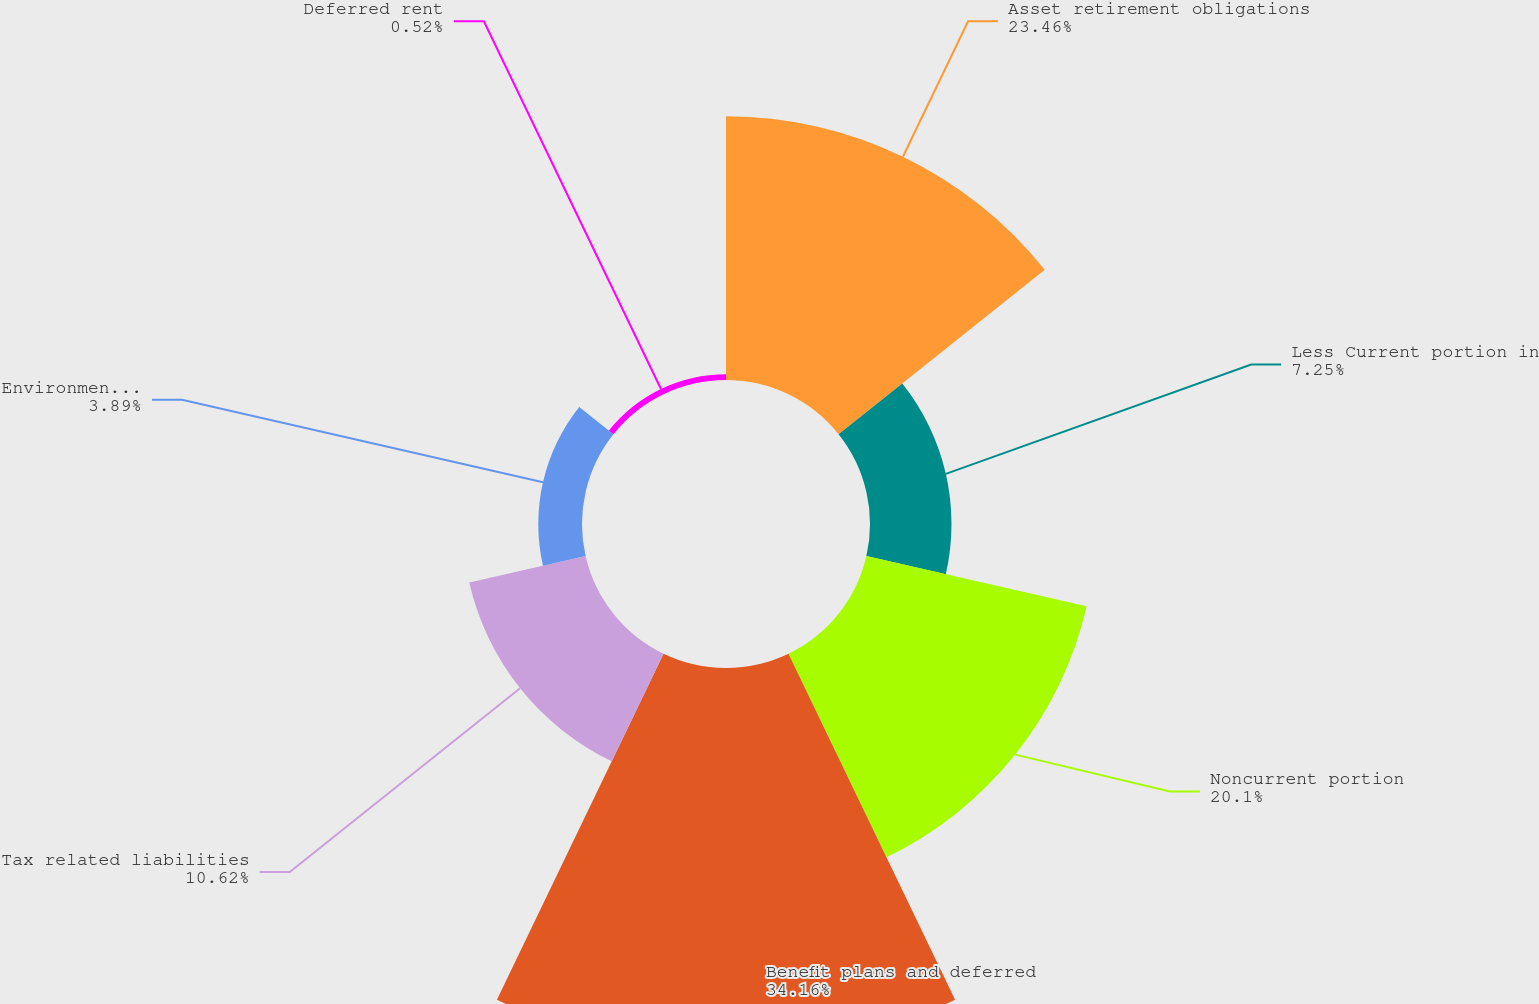<chart> <loc_0><loc_0><loc_500><loc_500><pie_chart><fcel>Asset retirement obligations<fcel>Less Current portion in<fcel>Noncurrent portion<fcel>Benefit plans and deferred<fcel>Tax related liabilities<fcel>Environmental and related<fcel>Deferred rent<nl><fcel>23.46%<fcel>7.25%<fcel>20.1%<fcel>34.17%<fcel>10.62%<fcel>3.89%<fcel>0.52%<nl></chart> 